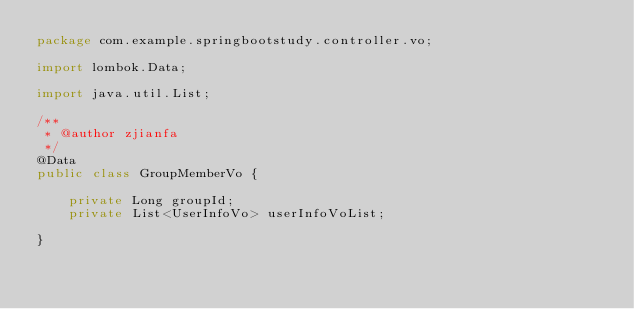Convert code to text. <code><loc_0><loc_0><loc_500><loc_500><_Java_>package com.example.springbootstudy.controller.vo;

import lombok.Data;

import java.util.List;

/**
 * @author zjianfa
 */
@Data
public class GroupMemberVo {

    private Long groupId;
    private List<UserInfoVo> userInfoVoList;

}
</code> 